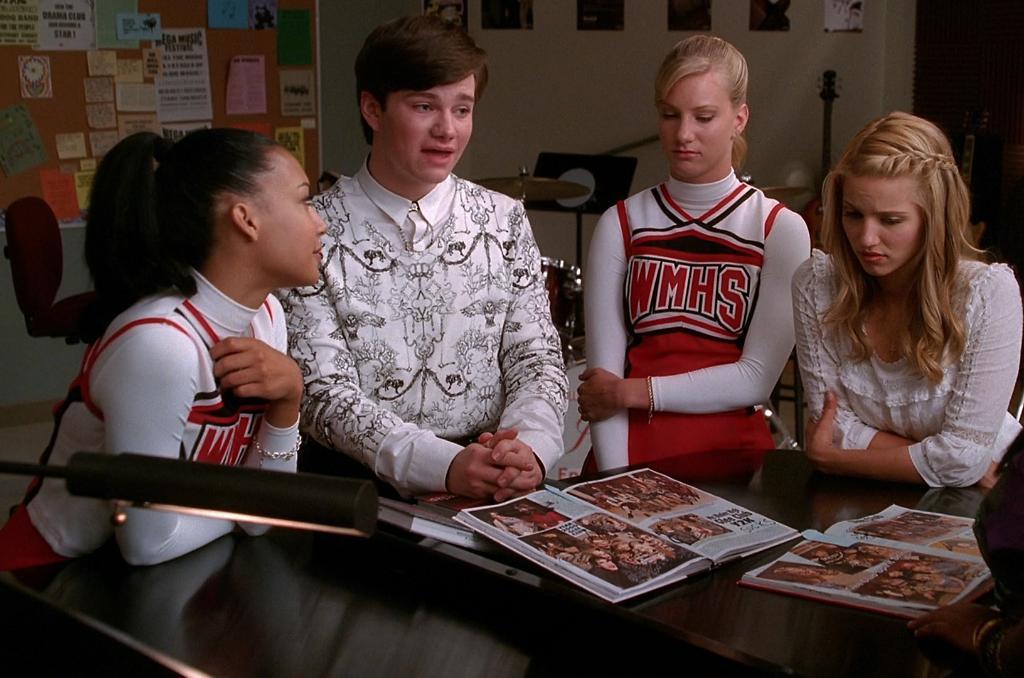What are the letters on the girls uniform?
Offer a very short reply. Wmhs. What does his shirt say on it?
Make the answer very short. Unanswerable. 